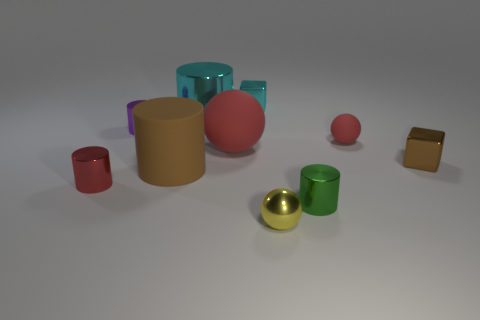What number of other objects are the same material as the small green object?
Provide a succinct answer. 6. Do the small red object that is behind the big brown matte object and the small thing that is behind the big cyan metallic thing have the same material?
Your answer should be compact. No. How many shiny things are in front of the small brown metal block and on the left side of the small yellow object?
Ensure brevity in your answer.  1. Is there a brown thing of the same shape as the tiny cyan shiny object?
Ensure brevity in your answer.  Yes. There is a cyan thing that is the same size as the purple object; what is its shape?
Your response must be concise. Cube. Is the number of brown rubber things that are behind the large cyan shiny cylinder the same as the number of cyan blocks that are to the left of the large brown object?
Give a very brief answer. Yes. There is a red thing right of the red sphere that is on the left side of the tiny rubber sphere; how big is it?
Offer a terse response. Small. Are there any brown objects that have the same size as the cyan cylinder?
Keep it short and to the point. Yes. What color is the sphere that is the same material as the tiny green cylinder?
Make the answer very short. Yellow. Is the number of tiny matte balls less than the number of big shiny cubes?
Provide a short and direct response. No. 